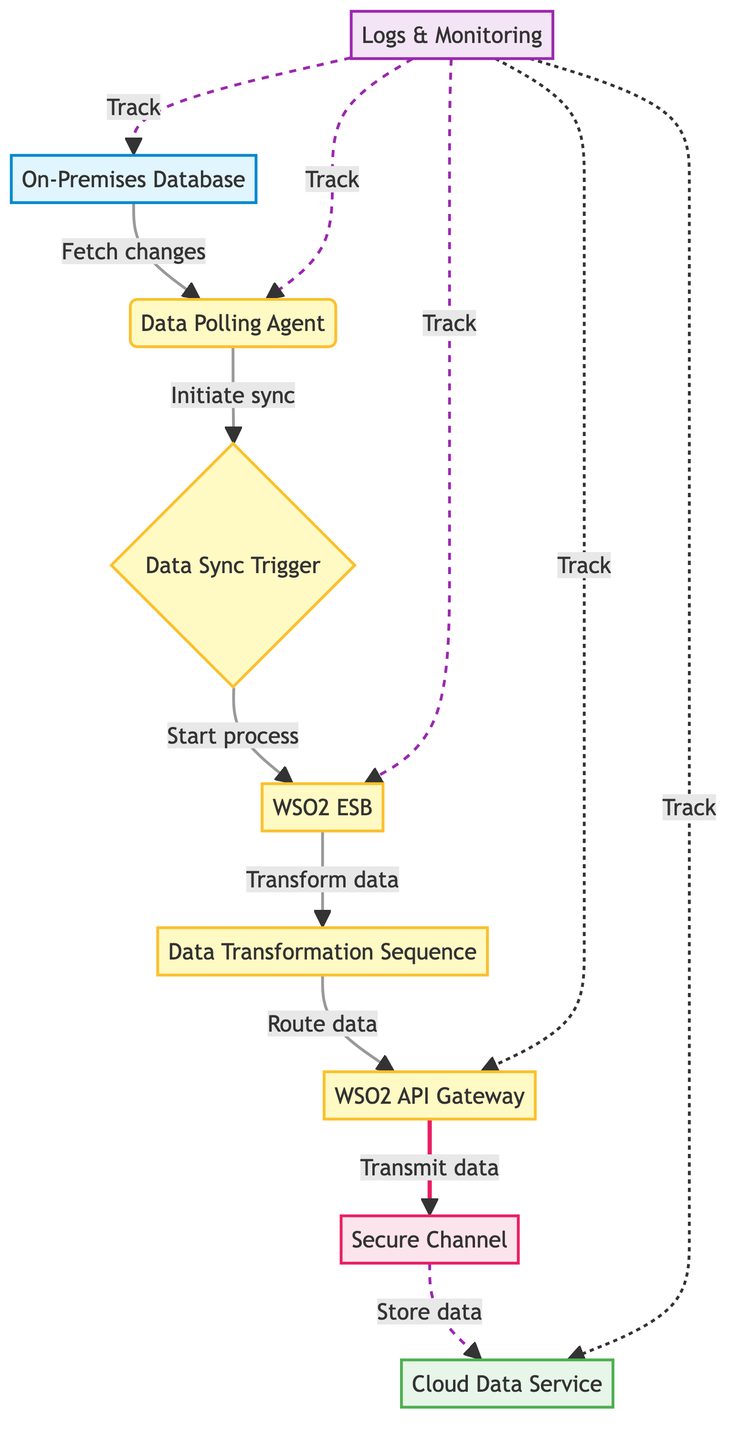What's the first step in the flowchart? The flowchart starts with the "On-Premises Database," which is the data source where real-time transactional data is stored. This can be seen at the top left of the diagram, indicating that this is the initial point where data originates.
Answer: On-Premises Database How many total nodes are present in the diagram? The diagram includes 10 distinct nodes, each representing different components and processes involved in the real-time data synchronization. Counting all labeled elements gives this total.
Answer: 10 What does the "Data Sync Trigger" do in the process? The "Data Sync Trigger" initiates the synchronization process by responding to an event or a scheduled job initiated by the Data Polling Agent. This indicates its role as a key transition element within the flowchart, connecting the Data Polling Agent to the WSO2 ESB.
Answer: Initiate sync Which node handles data transformation? The "Data Transformation Sequence" node is specifically designed to handle the transformation of data format, allowing it to match the requirements of the cloud service. This is clear from the directed flow from the WSO2 ESB to this process.
Answer: Data Transformation Sequence What is the purpose of the "Secure Channel"? The "Secure Channel" is crucial for ensuring that data transmission between on-premises systems and the cloud is secured using SSL/TLS protocols. This node highlights the importance of security in data synchronization within the flowchart.
Answer: Safe data transmission How does data move from the "WSO2 ESB" to the "Cloud Data Service"? Data flows from the "WSO2 ESB" to the "Cloud Data Service" through the "Data Transformation Sequence," which transforms the data to a suitable format, and is then routed via the "WSO2 API Gateway," before transmission through the "Secure Channel." This sequential pathway illustrates how data goes through transformations and routing to reach its destination.
Answer: Through the API Gateway Which part of the diagram is responsible for logs and monitoring? The "Logs & Monitoring" node signifies the centralized system that tracks and monitors the entire synchronization process, indicating its vital role in ensuring smooth operation and troubleshooting. This is illustrated by the dotted lines connecting it to various nodes in the flowchart.
Answer: Logs & Monitoring What is the type of the "Cloud Data Service"? The "Cloud Data Service" is categorized as a "Data Sink," which means it is the destination where the synchronized data is stored after being transmitted from the on-premises system. This classification can be observed from the type assigned in the diagram.
Answer: Data Sink 